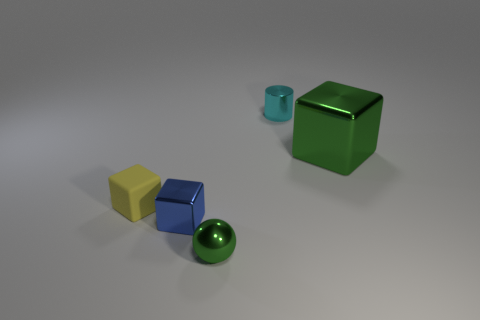There is a green object on the right side of the tiny object behind the metallic block right of the green sphere; what is it made of? metal 